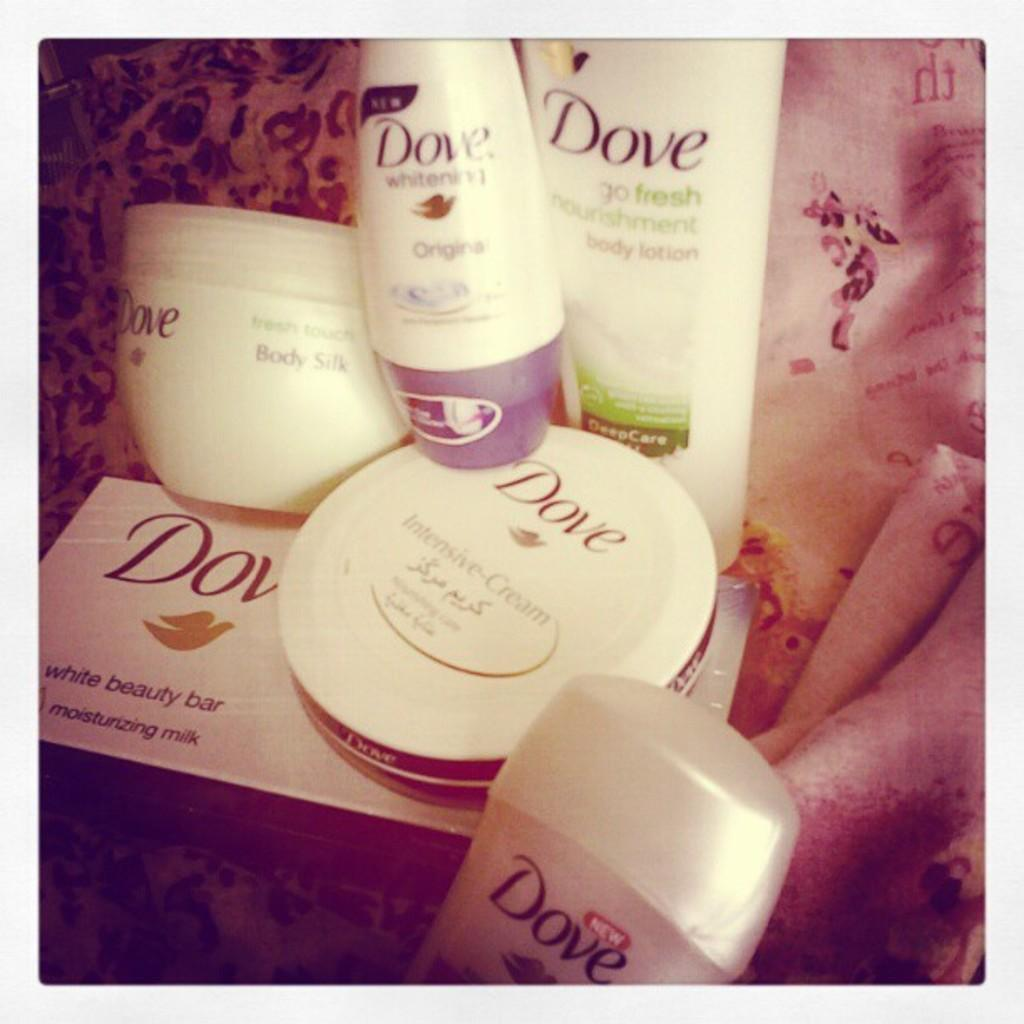What type of objects can be seen in the image? There are bottles and boxes in the image. What distinguishes the bottles and boxes from each other? The bottles and boxes have names and logos on them. What can be seen in the background of the image? There is cloth visible in the background of the image. What type of gun is being used during the protest in the image? There is no gun or protest present in the image; it only features bottles, boxes, and cloth in the background. 